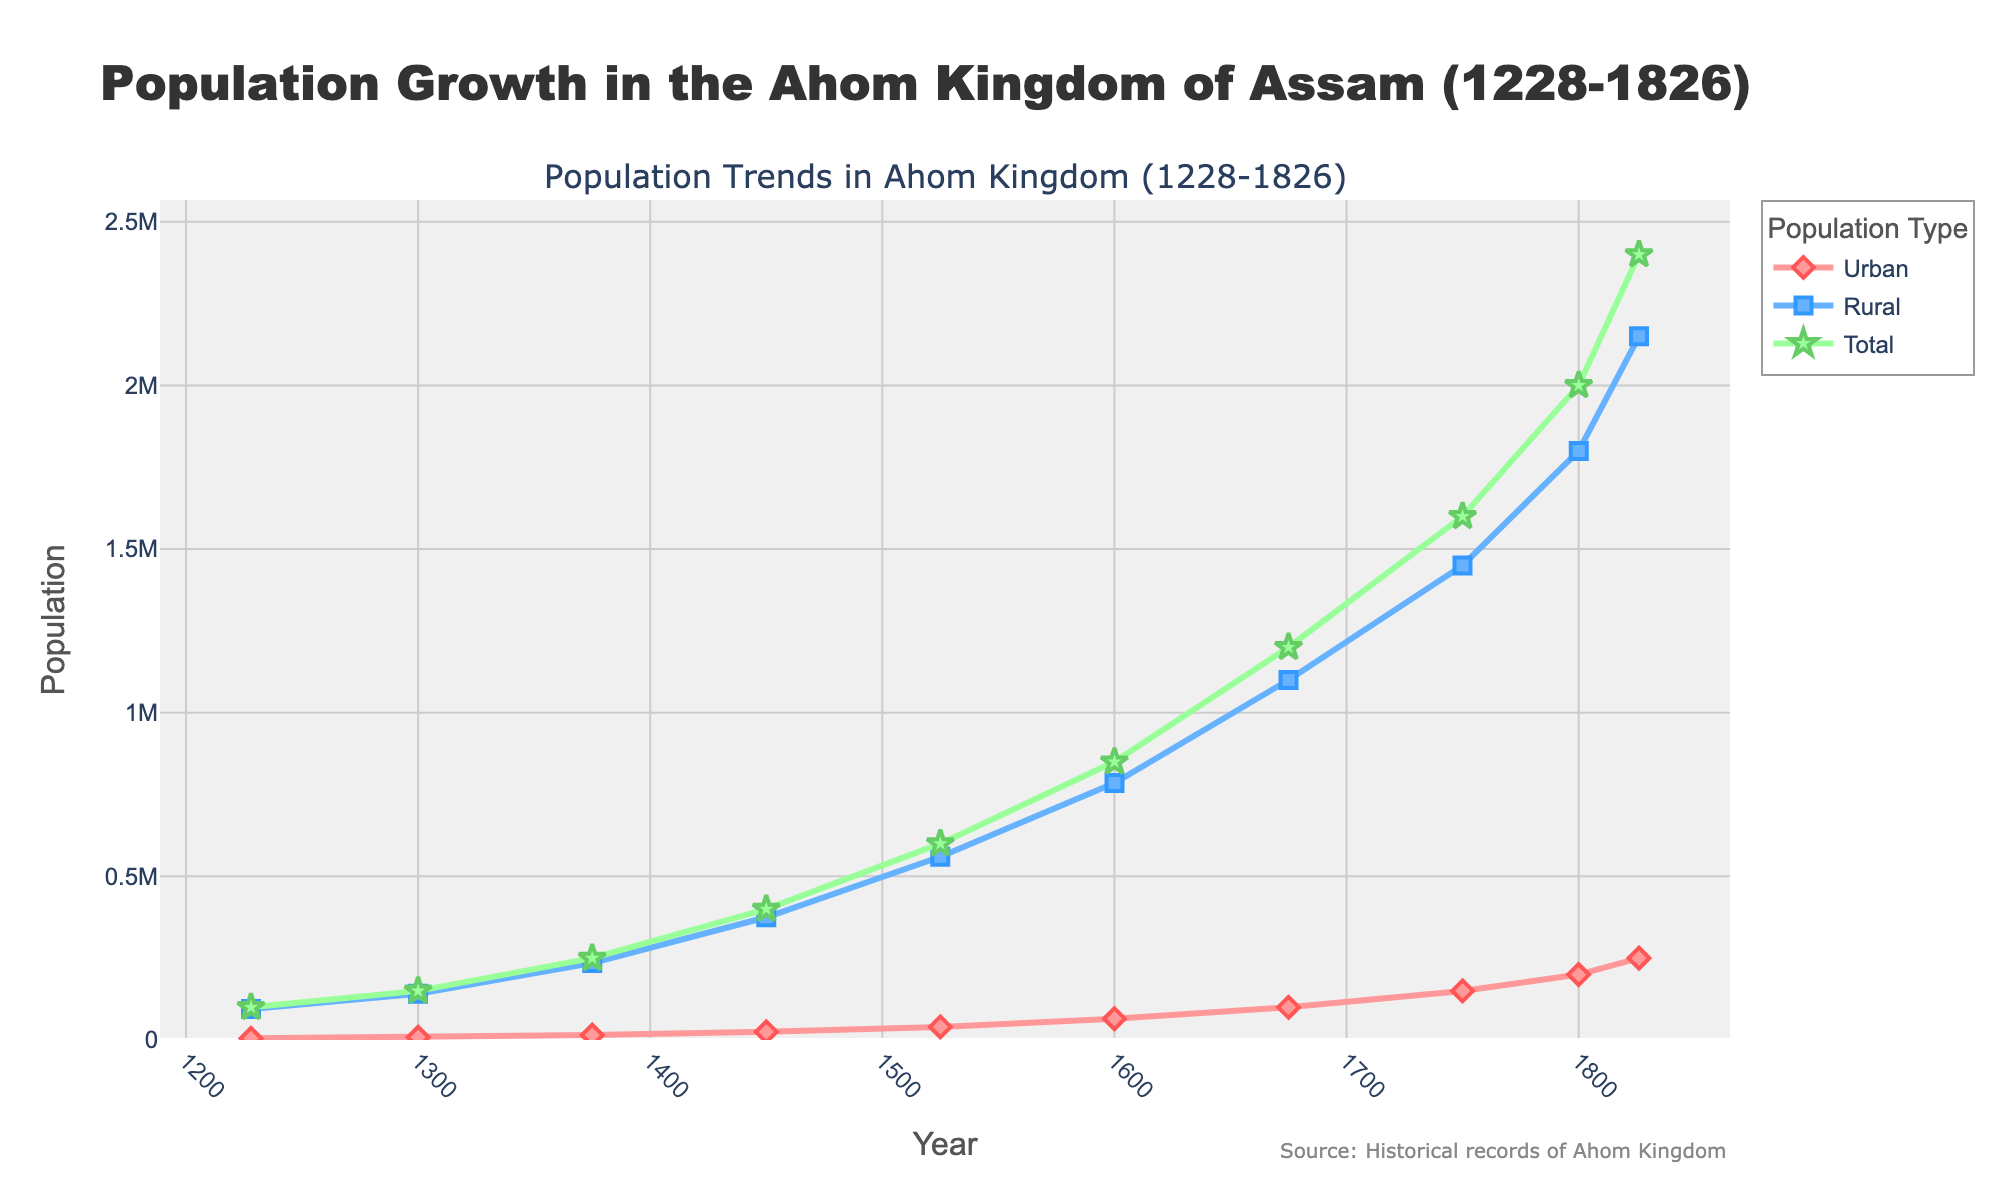How did the urban and rural populations compare in the year 1600? The chart shows two lines for urban and rural populations over the years. For the year 1600, the urban population is 65,000, and the rural population is 785,000. Comparing these two values, the rural population is significantly higher than the urban population.
Answer: The rural population was much higher What is the overall trend of the total population from 1228 to 1826? Observing the upward-sloping line for the total population from 1228 to 1826, it shows a consistent increase over the years, going from 100,000 in 1228 to 2,400,000 in 1826.
Answer: Consistently increasing What were the populations for the urban and rural areas in 1750? Refer to the specific points for the year 1750 on the two lines representing urban and rural populations. The chart indicates that the urban population was 150,000 and the rural population was 1,450,000 in 1750.
Answer: Urban: 150,000, Rural: 1,450,000 What is the average total population between 1228 and 1826? To find the average total population, sum up all the total population values given: 100,000 + 150,000 + 250,000 + 400,000 + 600,000 + 850,000 + 1,200,000 + 1,600,000 + 2,000,000 + 2,400,000 = 9,550,000. Divide this sum by the number of years provided (10): 9,550,000 / 10 = 955,000.
Answer: 955,000 Which population type increased more rapidly between 1450 and 1525? Calculate the change in population for both urban and rural types between these years. Urban increased from 25,000 to 40,000, a change of 15,000. Rural increased from 375,000 to 560,000, a change of 185,000. Despite the rural change being larger in absolute terms, both populations need to be considered in context. The overall percentage increase (proportionally) for urban is higher: 60% versus 49%.
Answer: The urban population How much did the total population grow from 1750 to 1800? Check the difference between the total population values for 1750 and 1800. It grew from 1,600,000 in 1750 to 2,000,000 in 1800. The difference is 2,000,000 - 1,600,000 = 400,000.
Answer: By 400,000 What is the trend difference between the urban and rural populations from the beginning to the end of the Ahom Kingdom? Compare the trend lines for urban and rural populations from 1228 to 1826. Both trends are upward, indicating growth, but the rural population consistently remains higher than the urban population throughout the time period.
Answer: Rural remained higher but both increased What was the fastest-growing period for the total population, and how can we spot it? Identify the segment where the total population line has the steepest upward slope between two consecutive data points. Between 1600 (850,000) and 1675 (1,200,000), the total population increased by 350,000, which is the largest absolute growth in a step compared to other periods.
Answer: 1600 to 1675 Which year had the smallest difference between urban and rural populations? Determine the difference in the populations for each year and compare them. In the earlier years, the differences are larger, while they tend to decrease more as time passes. By looking at the differences, notably in 1826, the urban (250,000) and rural (2,150,000) populations have a difference of 1,900,000, which is not the smallest. The smallest would be in the earlier period explored manually where urban and rural were relatively small.
Answer: Year 1228 (smallest contextually) How did the growth rates of urban and rural populations change over time? Examine the slopes of the lines visually; for urban, the line becomes steeper, implying acceleration, especially from 1600 onwards. For rural, the increase is steadier but eventually more consistent in absolute terms. The urban growth rate accelerates more noticeably compared to rural growth.
Answer: Urban growth accelerated more rapidly 